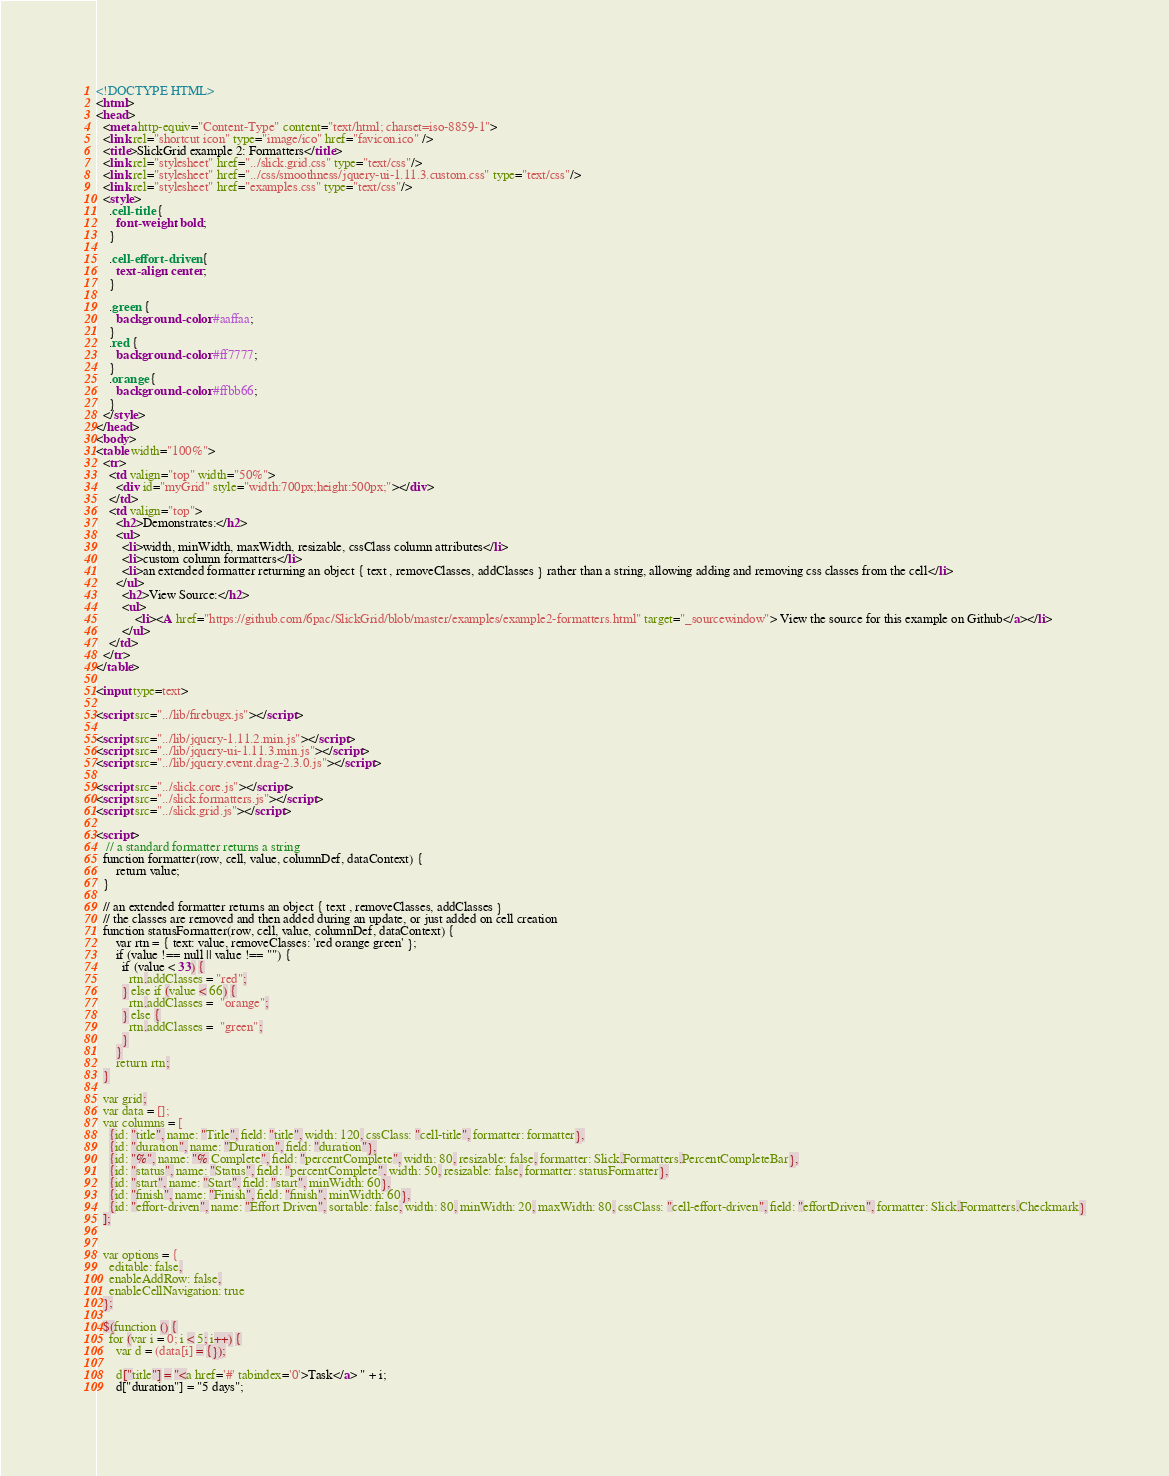<code> <loc_0><loc_0><loc_500><loc_500><_HTML_><!DOCTYPE HTML>
<html>
<head>
  <meta http-equiv="Content-Type" content="text/html; charset=iso-8859-1">
  <link rel="shortcut icon" type="image/ico" href="favicon.ico" />
  <title>SlickGrid example 2: Formatters</title>
  <link rel="stylesheet" href="../slick.grid.css" type="text/css"/>
  <link rel="stylesheet" href="../css/smoothness/jquery-ui-1.11.3.custom.css" type="text/css"/>
  <link rel="stylesheet" href="examples.css" type="text/css"/>
  <style>
    .cell-title {
      font-weight: bold;
    }

    .cell-effort-driven {
      text-align: center;
    }

    .green {
      background-color: #aaffaa;
    }      
    .red {
      background-color: #ff7777;
    }      
    .orange {
      background-color: #ffbb66;
    }      
  </style>
</head>
<body>
<table width="100%">
  <tr>
    <td valign="top" width="50%">
      <div id="myGrid" style="width:700px;height:500px;"></div>
    </td>
    <td valign="top">
      <h2>Demonstrates:</h2>
      <ul>
        <li>width, minWidth, maxWidth, resizable, cssClass column attributes</li>
        <li>custom column formatters</li>
        <li>an extended formatter returning an object { text , removeClasses, addClasses } rather than a string, allowing adding and removing css classes from the cell</li>
      </ul>
        <h2>View Source:</h2>
        <ul>
            <li><A href="https://github.com/6pac/SlickGrid/blob/master/examples/example2-formatters.html" target="_sourcewindow"> View the source for this example on Github</a></li>
        </ul>
    </td>
  </tr>
</table>

<input type=text>

<script src="../lib/firebugx.js"></script>

<script src="../lib/jquery-1.11.2.min.js"></script>
<script src="../lib/jquery-ui-1.11.3.min.js"></script>
<script src="../lib/jquery.event.drag-2.3.0.js"></script>

<script src="../slick.core.js"></script>
<script src="../slick.formatters.js"></script>
<script src="../slick.grid.js"></script>

<script>
   // a standard formatter returns a string 
  function formatter(row, cell, value, columnDef, dataContext) {
      return value;
  }

  // an extended formatter returns an object { text , removeClasses, addClasses }
  // the classes are removed and then added during an update, or just added on cell creation
  function statusFormatter(row, cell, value, columnDef, dataContext) {
      var rtn = { text: value, removeClasses: 'red orange green' };
      if (value !== null || value !== "") {
        if (value < 33) {
          rtn.addClasses = "red";
        } else if (value < 66) {
          rtn.addClasses =  "orange";
        } else {
          rtn.addClasses =  "green";
        }
      }
      return rtn;
  }

  var grid;
  var data = [];
  var columns = [
    {id: "title", name: "Title", field: "title", width: 120, cssClass: "cell-title", formatter: formatter},
    {id: "duration", name: "Duration", field: "duration"},
    {id: "%", name: "% Complete", field: "percentComplete", width: 80, resizable: false, formatter: Slick.Formatters.PercentCompleteBar},
    {id: "status", name: "Status", field: "percentComplete", width: 50, resizable: false, formatter: statusFormatter},
    {id: "start", name: "Start", field: "start", minWidth: 60},
    {id: "finish", name: "Finish", field: "finish", minWidth: 60},
    {id: "effort-driven", name: "Effort Driven", sortable: false, width: 80, minWidth: 20, maxWidth: 80, cssClass: "cell-effort-driven", field: "effortDriven", formatter: Slick.Formatters.Checkmark}
  ];

  
  var options = {
    editable: false,
    enableAddRow: false,
    enableCellNavigation: true
  };

  $(function () {
    for (var i = 0; i < 5; i++) {
      var d = (data[i] = {});

      d["title"] = "<a href='#' tabindex='0'>Task</a> " + i;
      d["duration"] = "5 days";</code> 